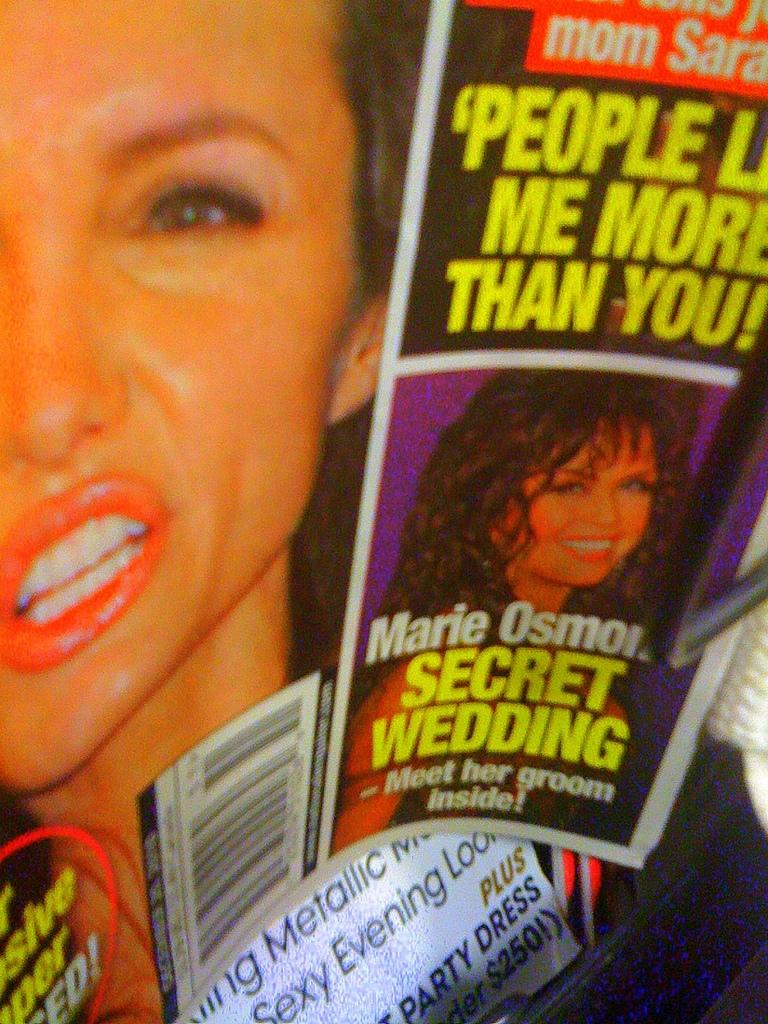<image>
Summarize the visual content of the image. A magazine cover has a section titled Marie Osmor Secret Wedding. 